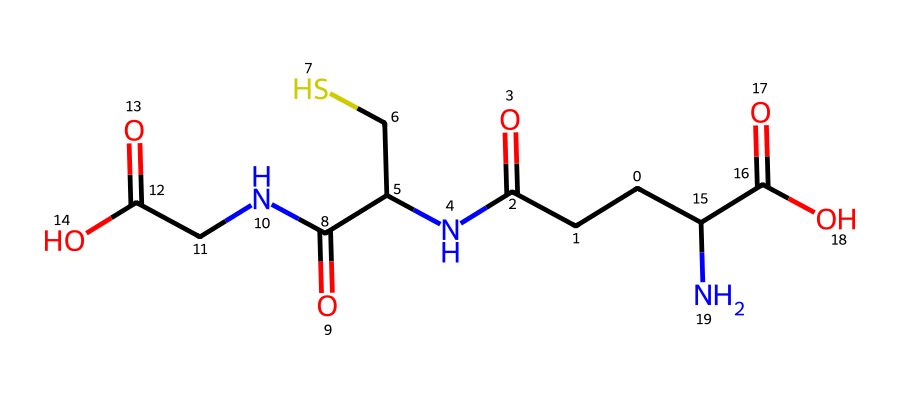How many carbon atoms are present in the molecule? Counting the number of carbon (C) atoms represented in the SMILES, I see five distinct carbon atoms.
Answer: five What is the total number of nitrogen atoms in the chemical structure? Reviewing the SMILES representation, I can identify two nitrogen (N) atoms within the compound.
Answer: two What type of functional groups are involved in this molecule? Analyzing the structure, I notice the presence of both amide (due to the nitrogen attached to carbonyls) and carboxylic acid functional groups.
Answer: amide and carboxylic acid What is the significance of the thiol (-SH) group in this antioxidant? The thiol group contributes to the antioxidant properties by allowing glutathione to donate electrons and neutralize free radicals, crucial for cellular protection.
Answer: antioxidant properties Are there any double bonds present in the molecular structure? Examining the representation reveals that there are two carbonyl groups (C=O), which indicates the presence of double bonds.
Answer: yes What role does glutathione play in cellular health? Glutathione acts as a critical antioxidant, helping to protect cells from oxidative stress and maintain overall cellular function.
Answer: antioxidant 